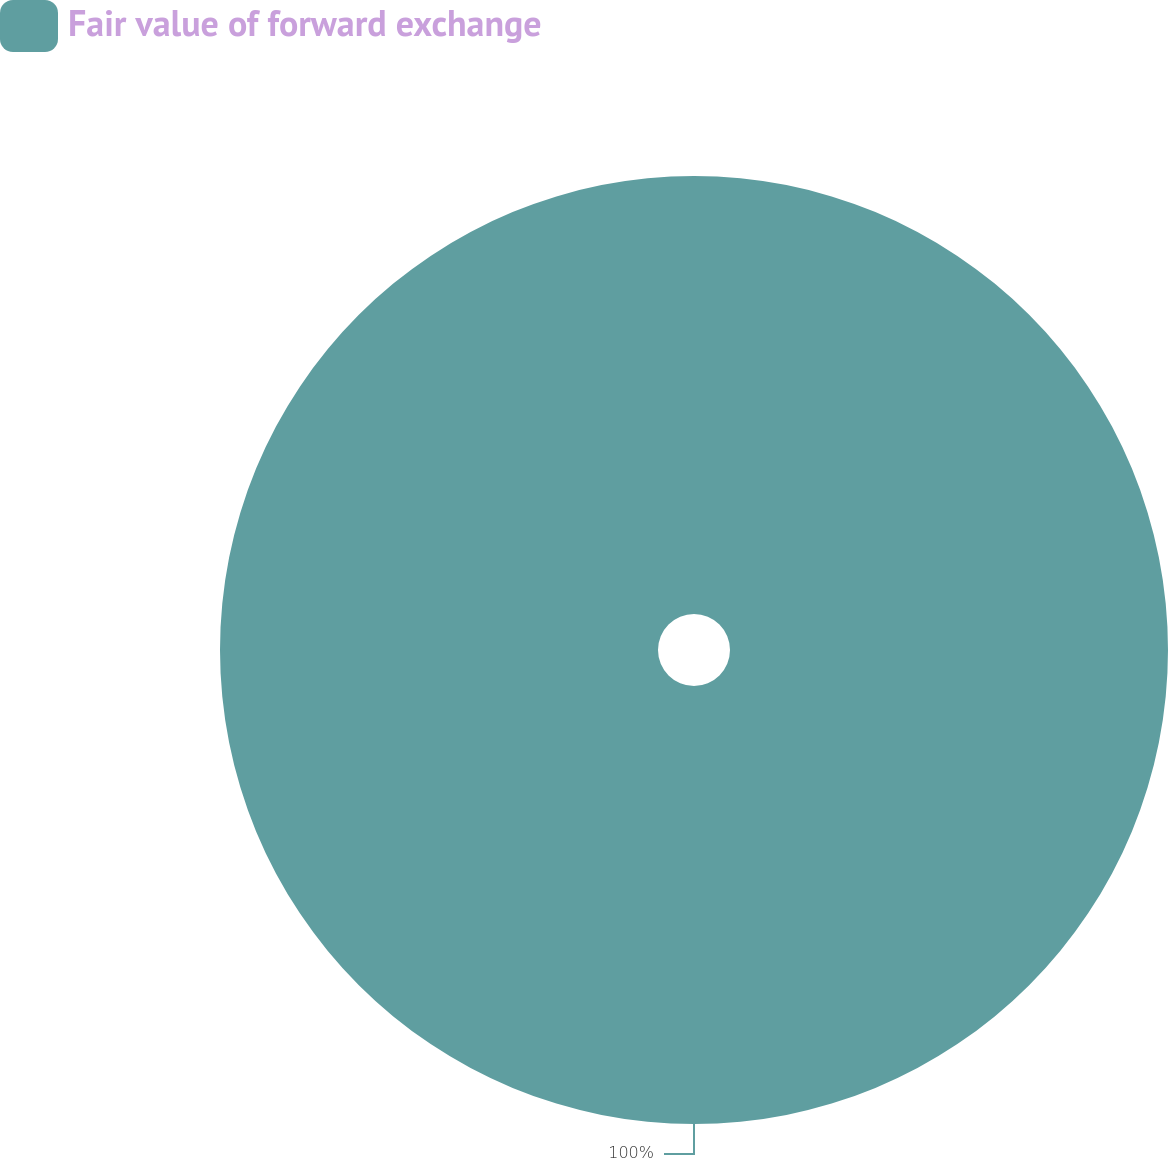Convert chart. <chart><loc_0><loc_0><loc_500><loc_500><pie_chart><fcel>Fair value of forward exchange<nl><fcel>100.0%<nl></chart> 